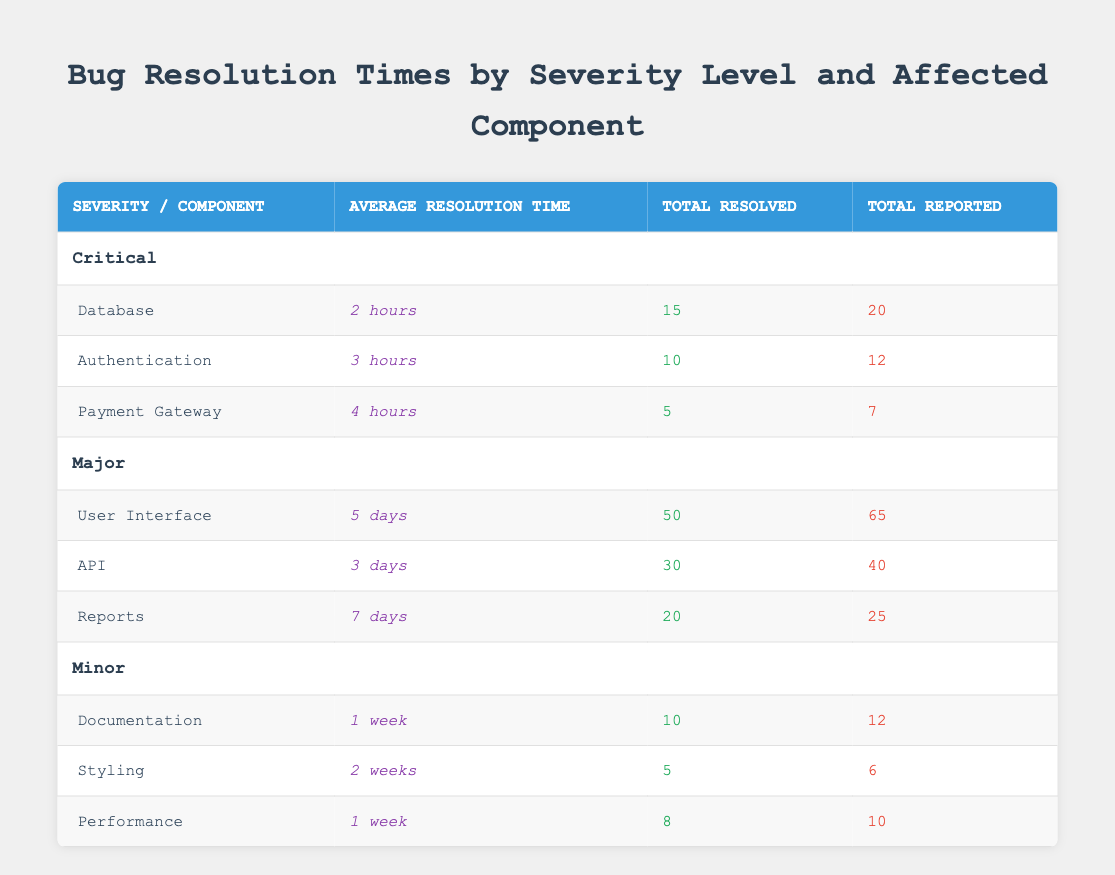What is the average resolution time for bugs in the Database component? The average resolution time for the Database component is explicitly provided in the table. It states that the average resolution time is 2 hours.
Answer: 2 hours How many total bugs were reported for the Authentication component? The table shows that the total reported bugs for the Authentication component are 12.
Answer: 12 What is the total number of Major bugs resolved across all components? To find the total resolved Major bugs, I add the totals from each component: 50 (User Interface) + 30 (API) + 20 (Reports) = 100.
Answer: 100 Is the average resolution time for Minor bugs shorter than that for Major bugs? I compare the average resolution times: Minor bugs have a resolution time of 1 week (7 days) for Documentation and Performance, and 2 weeks (14 days) for Styling. Major bugs have a minimum time of 3 days (API). Since 7 days is not shorter than 3 days, the statement is false.
Answer: No What component had the highest average resolution time among Major severity levels? First, I check the average resolution times for Major components: 5 days (User Interface), 3 days (API), and 7 days (Reports). The highest is clearly the Reports component with 7 days.
Answer: Reports How many critical bugs were reported in total? I sum the total reported Critical bugs across all components: 20 (Database) + 12 (Authentication) + 7 (Payment Gateway) = 39.
Answer: 39 What is the average resolution time for Minor bugs? I calculate the average resolution time for Minor bugs: Documentation (1 week), Styling (2 weeks), and Performance (1 week), which equals (7 days + 14 days + 7 days) / 3 = 9.33 days or approximately 1.33 weeks.
Answer: 1.33 weeks Did the Payment Gateway component have more reported bugs than the Authentication component? To answer this, I compare their reported numbers: Payment Gateway has 7 reported bugs while Authentication has 12. Since 7 is less than 12, the answer is no.
Answer: No 